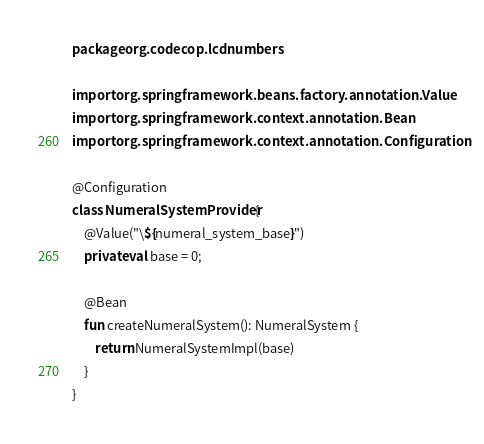Convert code to text. <code><loc_0><loc_0><loc_500><loc_500><_Kotlin_>package org.codecop.lcdnumbers

import org.springframework.beans.factory.annotation.Value
import org.springframework.context.annotation.Bean
import org.springframework.context.annotation.Configuration

@Configuration
class NumeralSystemProvider {
    @Value("\${numeral_system_base}")
    private val base = 0;

    @Bean
    fun createNumeralSystem(): NumeralSystem {
        return NumeralSystemImpl(base)
    }
}</code> 